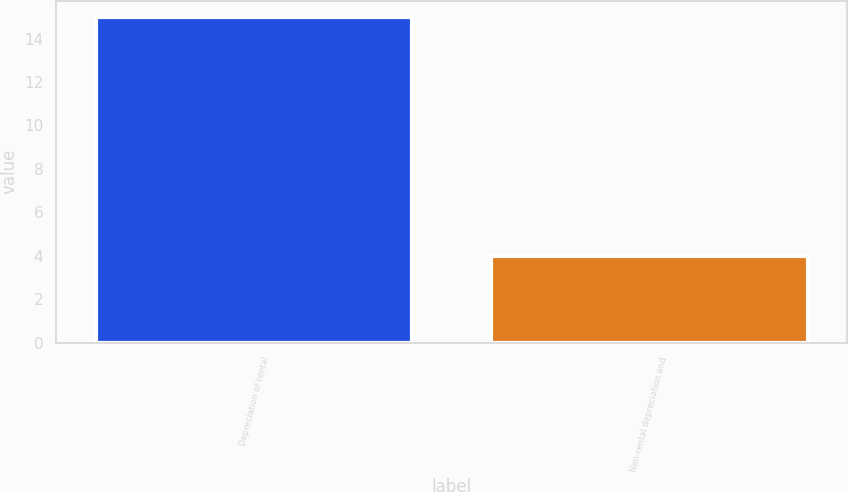<chart> <loc_0><loc_0><loc_500><loc_500><bar_chart><fcel>Depreciation of rental<fcel>Non-rental depreciation and<nl><fcel>15<fcel>4<nl></chart> 